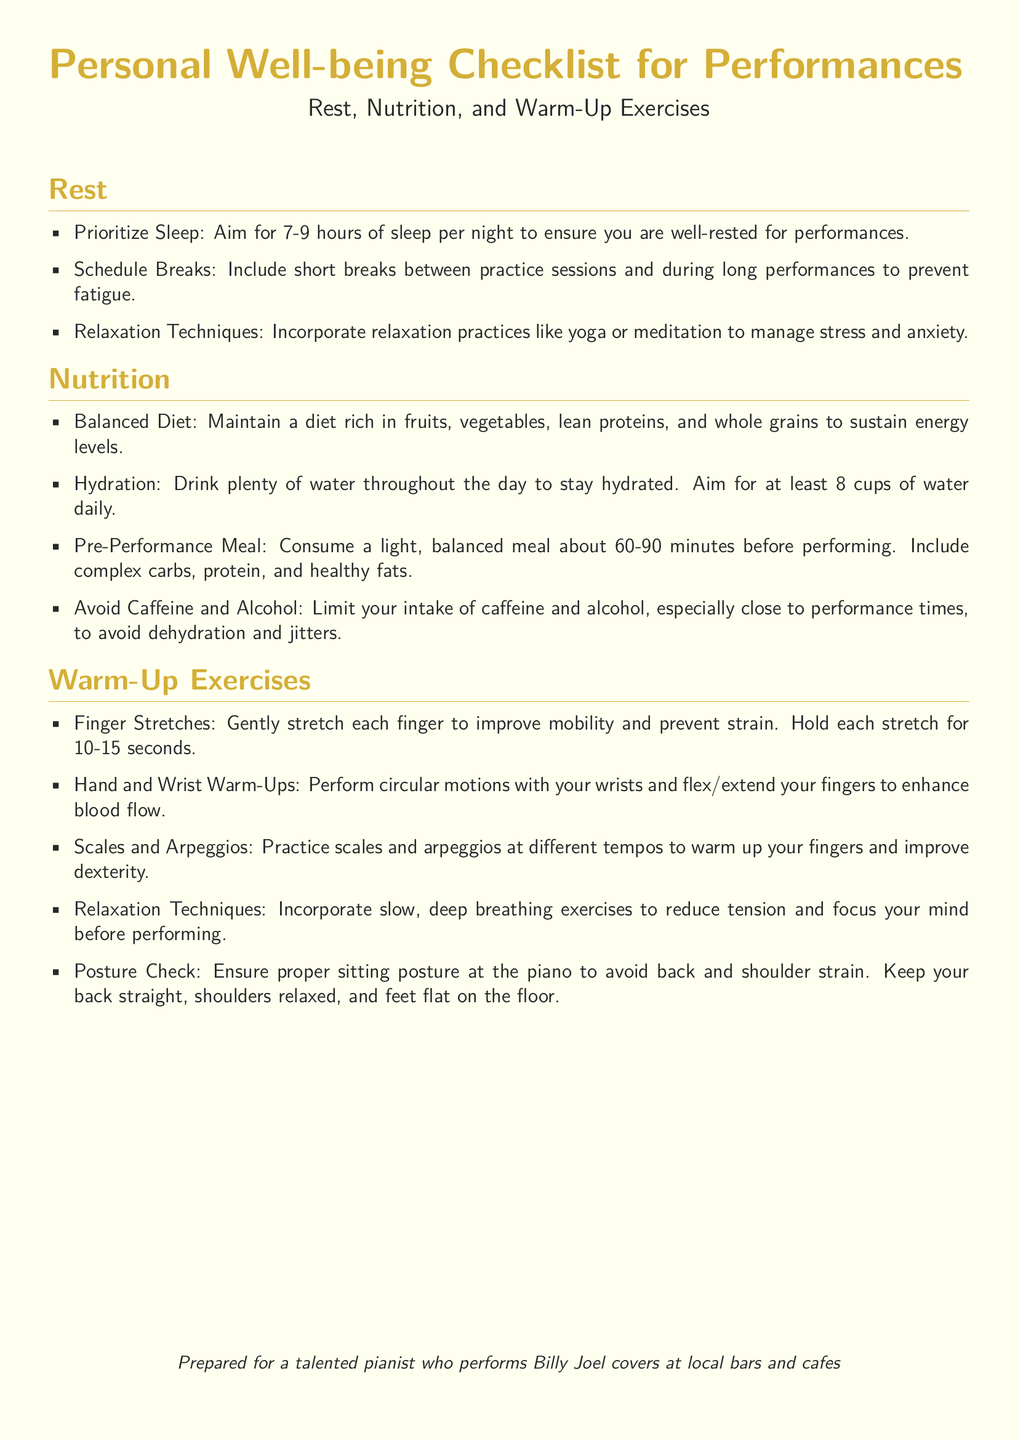What is the recommended amount of sleep per night? The document suggests aiming for 7-9 hours of sleep per night for being well-rested for performances.
Answer: 7-9 hours What is included in the pre-performance meal? It should include complex carbs, protein, and healthy fats, according to the nutrition section.
Answer: Complex carbs, protein, and healthy fats How long before a performance should the pre-performance meal be consumed? The document advises having the meal about 60-90 minutes before performing.
Answer: 60-90 minutes What exercise helps improve mobility and prevent strain in fingers? Finger stretches are mentioned as a practice to improve mobility and prevent strain.
Answer: Finger stretches What should be checked to ensure proper sitting posture? The document states that a posture check should be performed to avoid back and shoulder strain.
Answer: Posture check What is a recommended hydration goal per day? The checklist recommends drinking at least 8 cups of water daily to stay hydrated.
Answer: 8 cups Which relaxation practice is suggested to manage stress? The document mentions incorporating yoga or meditation as relaxation techniques.
Answer: Yoga or meditation What type of diet should be maintained for sustained energy levels? The document emphasizes maintaining a balanced diet rich in fruits, vegetables, lean proteins, and whole grains.
Answer: Balanced diet What should be done to reduce tension before performing? The checklist suggests incorporating slow, deep breathing exercises to reduce tension.
Answer: Deep breathing exercises 